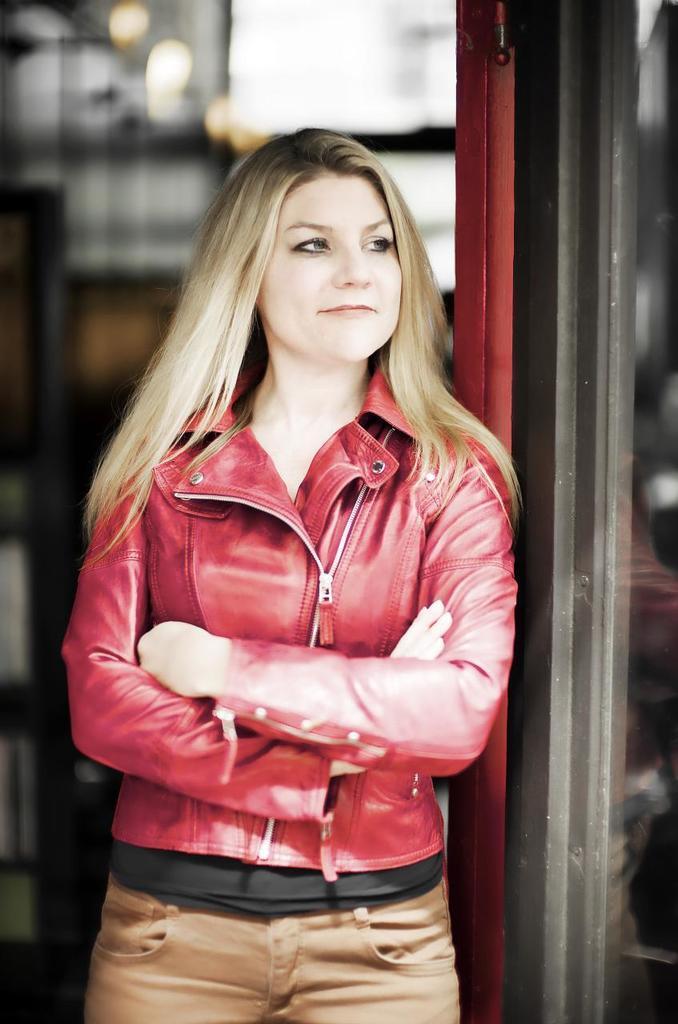Describe this image in one or two sentences. In the picture there is a woman, she is wearing red jacket and standing beside a door and the background of the woman is blur. 